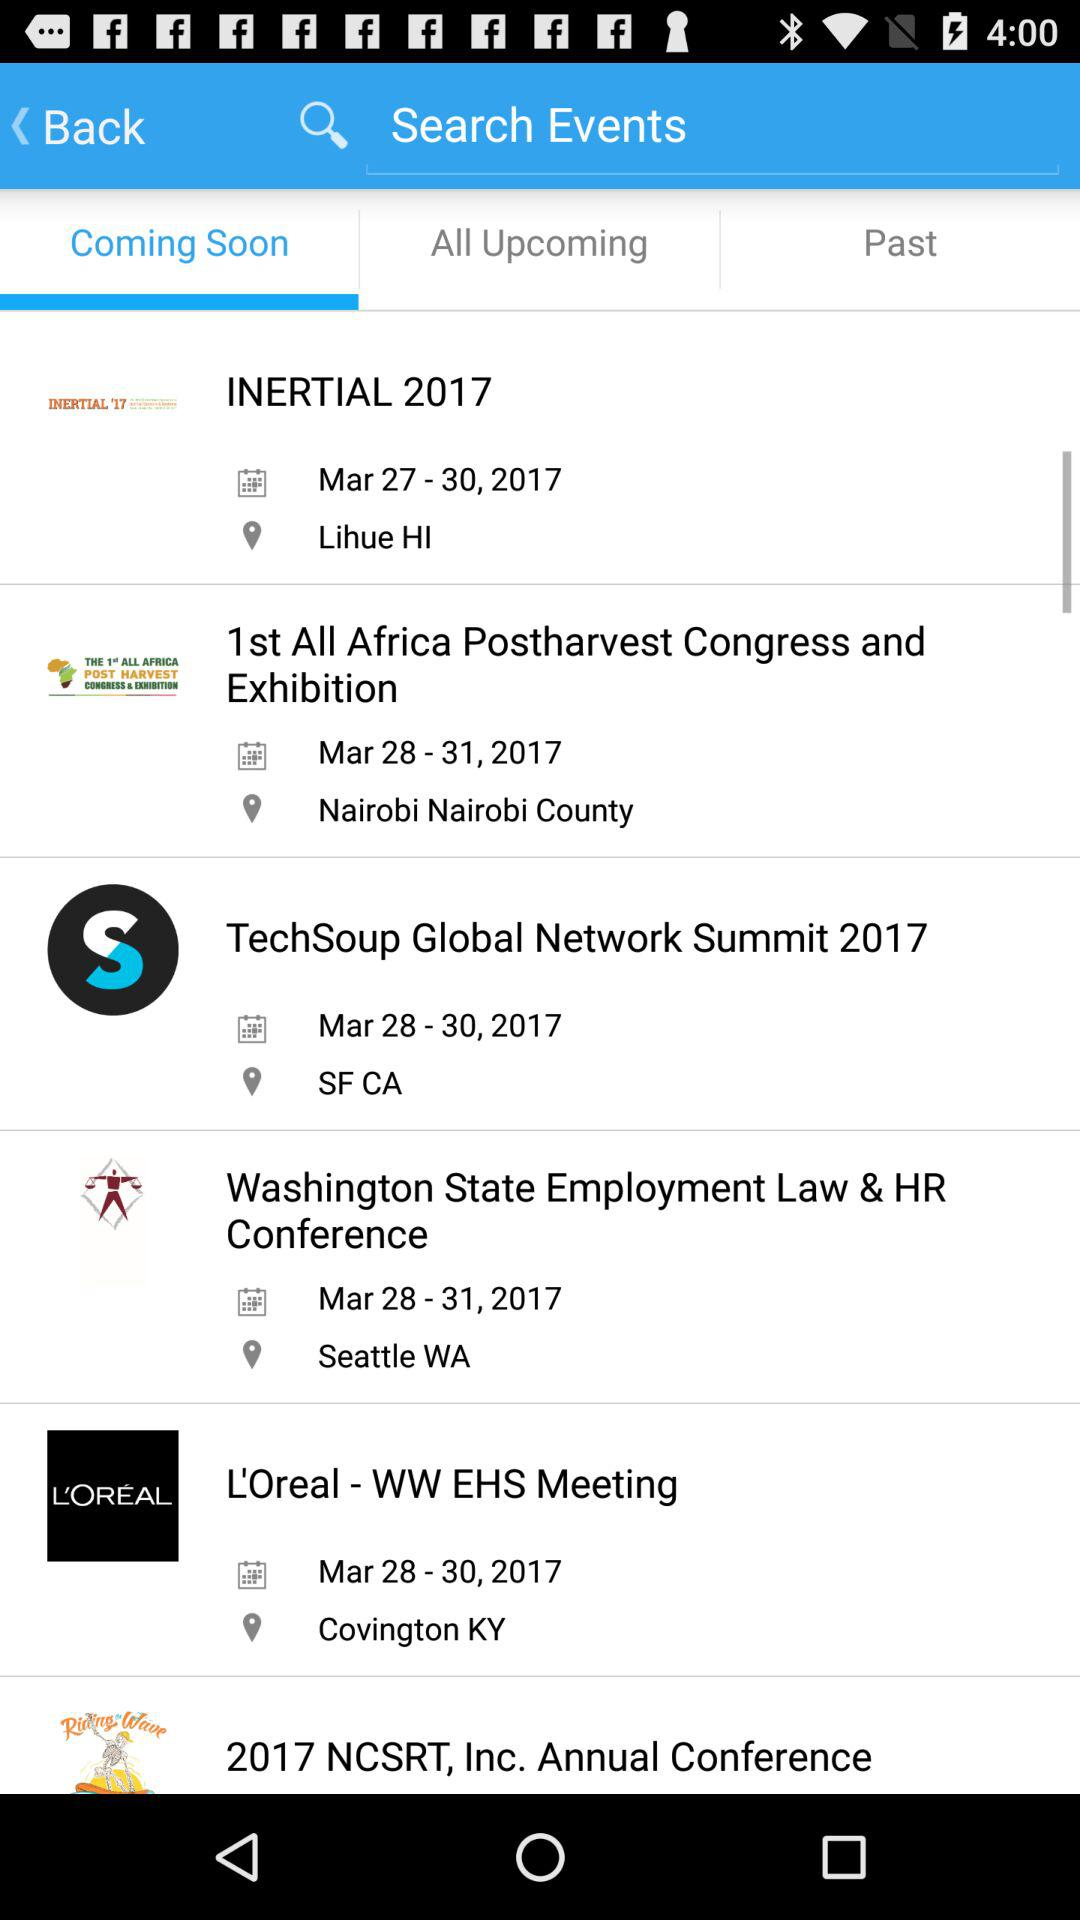On what date will the L'Oreal-WW EHS Meeting be held? The date is from March 28, 2017 to March 31, 2017. 